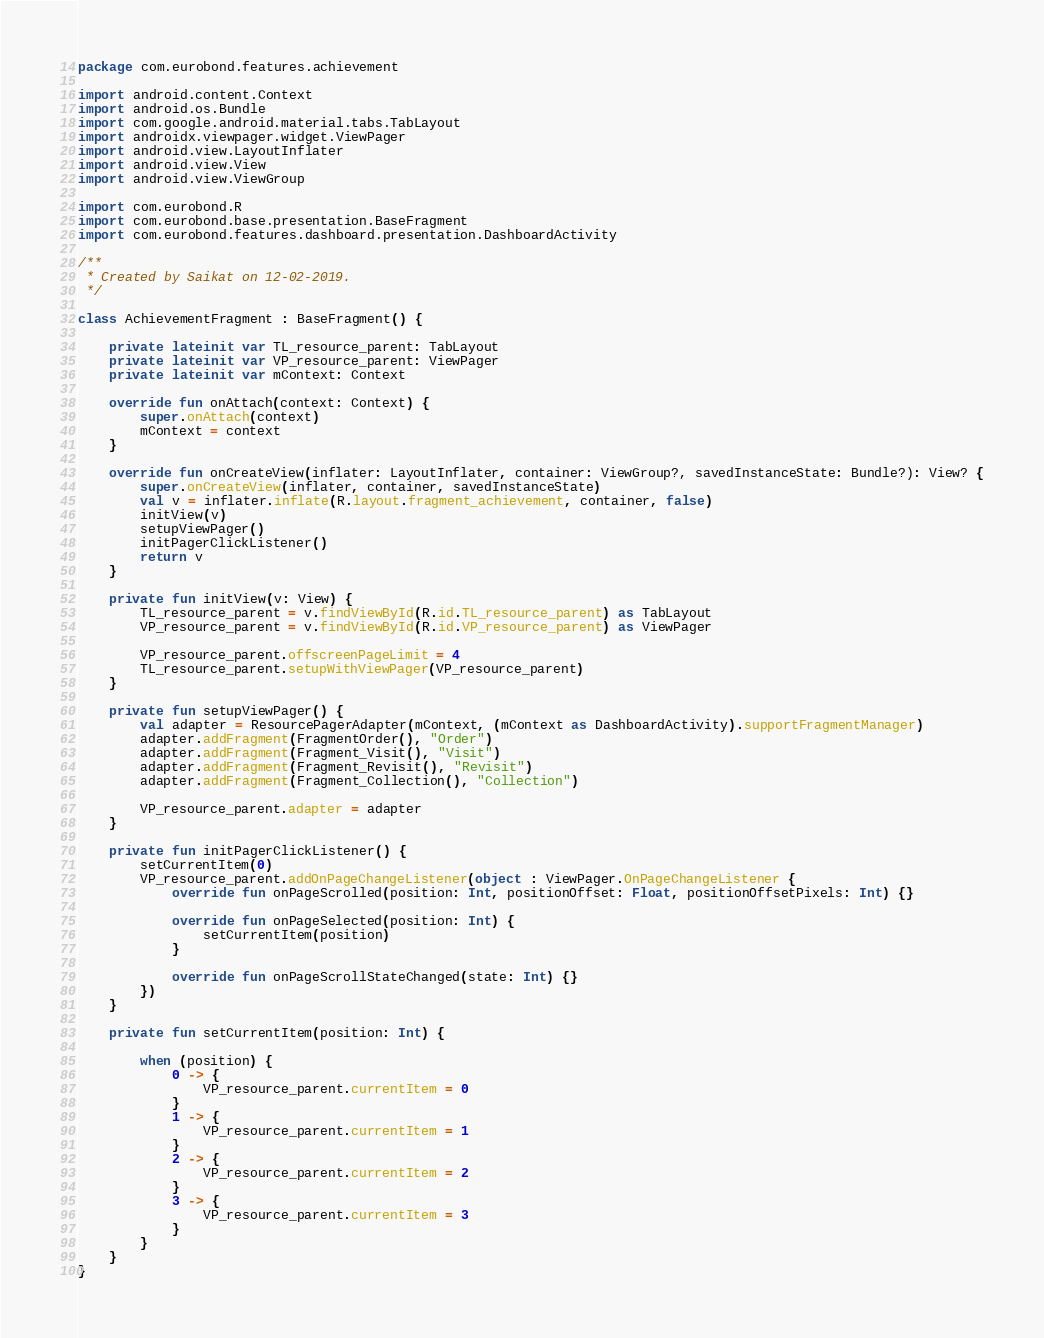Convert code to text. <code><loc_0><loc_0><loc_500><loc_500><_Kotlin_>package com.eurobond.features.achievement

import android.content.Context
import android.os.Bundle
import com.google.android.material.tabs.TabLayout
import androidx.viewpager.widget.ViewPager
import android.view.LayoutInflater
import android.view.View
import android.view.ViewGroup

import com.eurobond.R
import com.eurobond.base.presentation.BaseFragment
import com.eurobond.features.dashboard.presentation.DashboardActivity

/**
 * Created by Saikat on 12-02-2019.
 */

class AchievementFragment : BaseFragment() {

    private lateinit var TL_resource_parent: TabLayout
    private lateinit var VP_resource_parent: ViewPager
    private lateinit var mContext: Context

    override fun onAttach(context: Context) {
        super.onAttach(context)
        mContext = context
    }

    override fun onCreateView(inflater: LayoutInflater, container: ViewGroup?, savedInstanceState: Bundle?): View? {
        super.onCreateView(inflater, container, savedInstanceState)
        val v = inflater.inflate(R.layout.fragment_achievement, container, false)
        initView(v)
        setupViewPager()
        initPagerClickListener()
        return v
    }

    private fun initView(v: View) {
        TL_resource_parent = v.findViewById(R.id.TL_resource_parent) as TabLayout
        VP_resource_parent = v.findViewById(R.id.VP_resource_parent) as ViewPager

        VP_resource_parent.offscreenPageLimit = 4
        TL_resource_parent.setupWithViewPager(VP_resource_parent)
    }

    private fun setupViewPager() {
        val adapter = ResourcePagerAdapter(mContext, (mContext as DashboardActivity).supportFragmentManager)
        adapter.addFragment(FragmentOrder(), "Order")
        adapter.addFragment(Fragment_Visit(), "Visit")
        adapter.addFragment(Fragment_Revisit(), "Revisit")
        adapter.addFragment(Fragment_Collection(), "Collection")

        VP_resource_parent.adapter = adapter
    }

    private fun initPagerClickListener() {
        setCurrentItem(0)
        VP_resource_parent.addOnPageChangeListener(object : ViewPager.OnPageChangeListener {
            override fun onPageScrolled(position: Int, positionOffset: Float, positionOffsetPixels: Int) {}

            override fun onPageSelected(position: Int) {
                setCurrentItem(position)
            }

            override fun onPageScrollStateChanged(state: Int) {}
        })
    }

    private fun setCurrentItem(position: Int) {

        when (position) {
            0 -> {
                VP_resource_parent.currentItem = 0
            }
            1 -> {
                VP_resource_parent.currentItem = 1
            }
            2 -> {
                VP_resource_parent.currentItem = 2
            }
            3 -> {
                VP_resource_parent.currentItem = 3
            }
        }
    }
}
</code> 